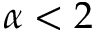<formula> <loc_0><loc_0><loc_500><loc_500>\alpha < 2</formula> 